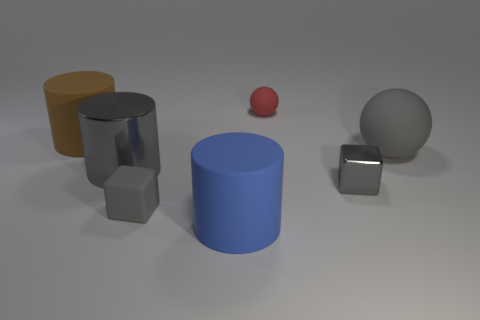Is the shape of the tiny red rubber thing the same as the large gray matte object?
Your response must be concise. Yes. There is a gray thing that is the same shape as the big brown rubber object; what material is it?
Your response must be concise. Metal. What number of large metallic things are the same color as the tiny shiny cube?
Your answer should be very brief. 1. There is a blue thing that is the same material as the small red object; what size is it?
Keep it short and to the point. Large. How many red things are balls or matte blocks?
Offer a very short reply. 1. There is a rubber object that is right of the small red ball; how many cubes are in front of it?
Provide a succinct answer. 2. Are there more metallic objects that are on the left side of the gray sphere than blue cylinders that are in front of the tiny red matte thing?
Offer a terse response. Yes. What is the material of the gray cylinder?
Give a very brief answer. Metal. Are there any metallic blocks that have the same size as the red thing?
Offer a very short reply. Yes. There is a gray cylinder that is the same size as the blue cylinder; what is its material?
Offer a terse response. Metal. 